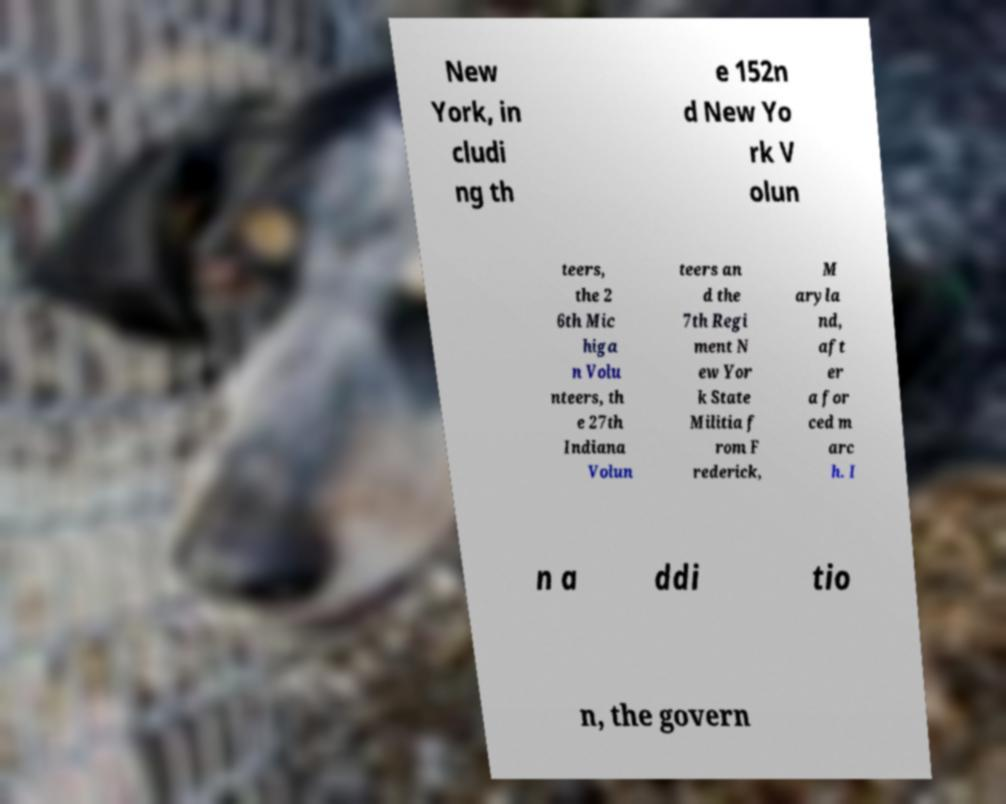Can you accurately transcribe the text from the provided image for me? New York, in cludi ng th e 152n d New Yo rk V olun teers, the 2 6th Mic higa n Volu nteers, th e 27th Indiana Volun teers an d the 7th Regi ment N ew Yor k State Militia f rom F rederick, M aryla nd, aft er a for ced m arc h. I n a ddi tio n, the govern 